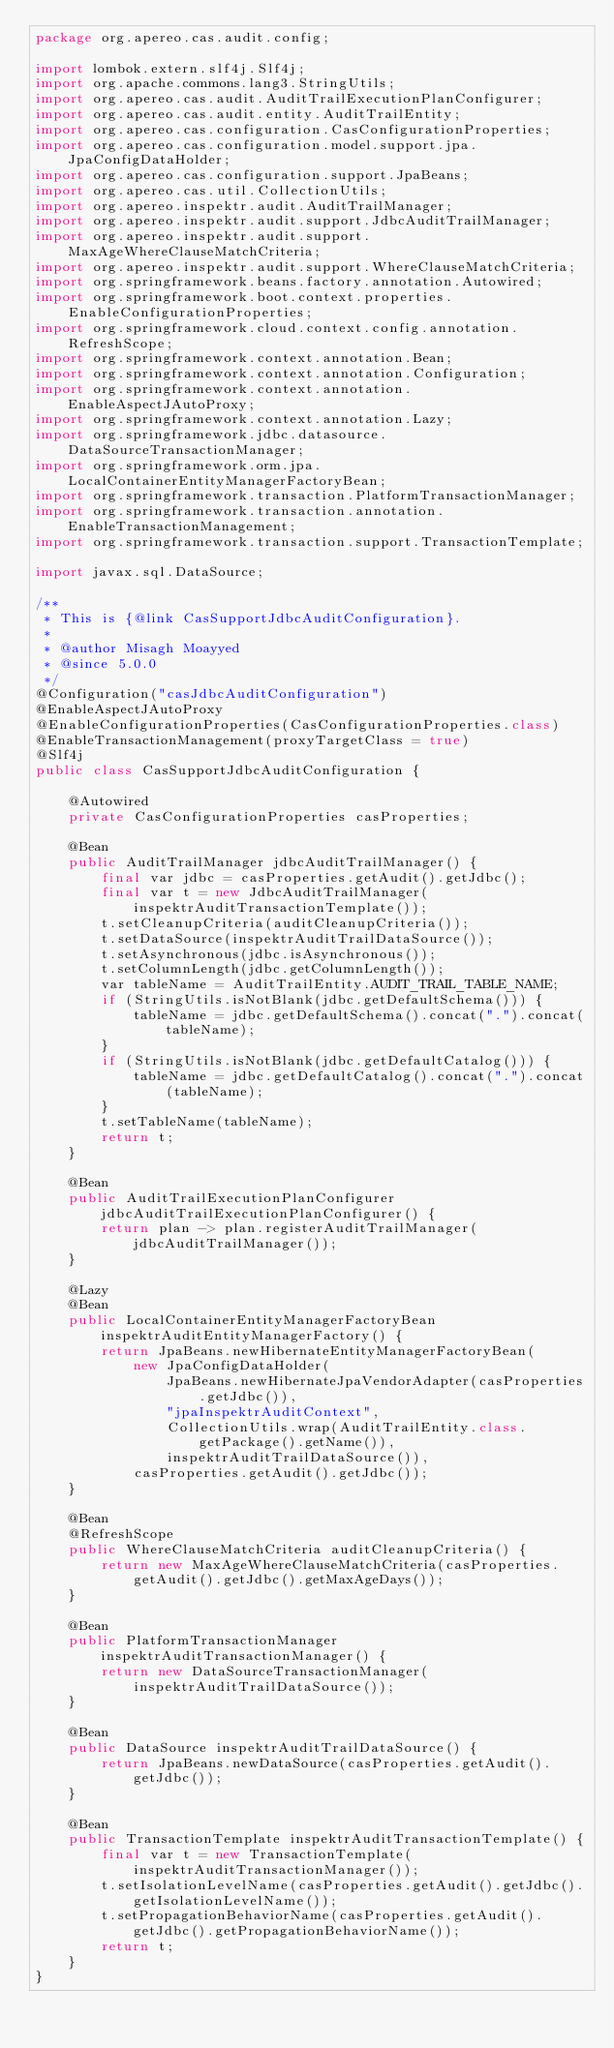<code> <loc_0><loc_0><loc_500><loc_500><_Java_>package org.apereo.cas.audit.config;

import lombok.extern.slf4j.Slf4j;
import org.apache.commons.lang3.StringUtils;
import org.apereo.cas.audit.AuditTrailExecutionPlanConfigurer;
import org.apereo.cas.audit.entity.AuditTrailEntity;
import org.apereo.cas.configuration.CasConfigurationProperties;
import org.apereo.cas.configuration.model.support.jpa.JpaConfigDataHolder;
import org.apereo.cas.configuration.support.JpaBeans;
import org.apereo.cas.util.CollectionUtils;
import org.apereo.inspektr.audit.AuditTrailManager;
import org.apereo.inspektr.audit.support.JdbcAuditTrailManager;
import org.apereo.inspektr.audit.support.MaxAgeWhereClauseMatchCriteria;
import org.apereo.inspektr.audit.support.WhereClauseMatchCriteria;
import org.springframework.beans.factory.annotation.Autowired;
import org.springframework.boot.context.properties.EnableConfigurationProperties;
import org.springframework.cloud.context.config.annotation.RefreshScope;
import org.springframework.context.annotation.Bean;
import org.springframework.context.annotation.Configuration;
import org.springframework.context.annotation.EnableAspectJAutoProxy;
import org.springframework.context.annotation.Lazy;
import org.springframework.jdbc.datasource.DataSourceTransactionManager;
import org.springframework.orm.jpa.LocalContainerEntityManagerFactoryBean;
import org.springframework.transaction.PlatformTransactionManager;
import org.springframework.transaction.annotation.EnableTransactionManagement;
import org.springframework.transaction.support.TransactionTemplate;

import javax.sql.DataSource;

/**
 * This is {@link CasSupportJdbcAuditConfiguration}.
 *
 * @author Misagh Moayyed
 * @since 5.0.0
 */
@Configuration("casJdbcAuditConfiguration")
@EnableAspectJAutoProxy
@EnableConfigurationProperties(CasConfigurationProperties.class)
@EnableTransactionManagement(proxyTargetClass = true)
@Slf4j
public class CasSupportJdbcAuditConfiguration {

    @Autowired
    private CasConfigurationProperties casProperties;

    @Bean
    public AuditTrailManager jdbcAuditTrailManager() {
        final var jdbc = casProperties.getAudit().getJdbc();
        final var t = new JdbcAuditTrailManager(inspektrAuditTransactionTemplate());
        t.setCleanupCriteria(auditCleanupCriteria());
        t.setDataSource(inspektrAuditTrailDataSource());
        t.setAsynchronous(jdbc.isAsynchronous());
        t.setColumnLength(jdbc.getColumnLength());
        var tableName = AuditTrailEntity.AUDIT_TRAIL_TABLE_NAME;
        if (StringUtils.isNotBlank(jdbc.getDefaultSchema())) {
            tableName = jdbc.getDefaultSchema().concat(".").concat(tableName);
        }
        if (StringUtils.isNotBlank(jdbc.getDefaultCatalog())) {
            tableName = jdbc.getDefaultCatalog().concat(".").concat(tableName);
        }
        t.setTableName(tableName);
        return t;
    }

    @Bean
    public AuditTrailExecutionPlanConfigurer jdbcAuditTrailExecutionPlanConfigurer() {
        return plan -> plan.registerAuditTrailManager(jdbcAuditTrailManager());
    }

    @Lazy
    @Bean
    public LocalContainerEntityManagerFactoryBean inspektrAuditEntityManagerFactory() {
        return JpaBeans.newHibernateEntityManagerFactoryBean(
            new JpaConfigDataHolder(
                JpaBeans.newHibernateJpaVendorAdapter(casProperties.getJdbc()),
                "jpaInspektrAuditContext",
                CollectionUtils.wrap(AuditTrailEntity.class.getPackage().getName()),
                inspektrAuditTrailDataSource()),
            casProperties.getAudit().getJdbc());
    }

    @Bean
    @RefreshScope
    public WhereClauseMatchCriteria auditCleanupCriteria() {
        return new MaxAgeWhereClauseMatchCriteria(casProperties.getAudit().getJdbc().getMaxAgeDays());
    }

    @Bean
    public PlatformTransactionManager inspektrAuditTransactionManager() {
        return new DataSourceTransactionManager(inspektrAuditTrailDataSource());
    }

    @Bean
    public DataSource inspektrAuditTrailDataSource() {
        return JpaBeans.newDataSource(casProperties.getAudit().getJdbc());
    }

    @Bean
    public TransactionTemplate inspektrAuditTransactionTemplate() {
        final var t = new TransactionTemplate(inspektrAuditTransactionManager());
        t.setIsolationLevelName(casProperties.getAudit().getJdbc().getIsolationLevelName());
        t.setPropagationBehaviorName(casProperties.getAudit().getJdbc().getPropagationBehaviorName());
        return t;
    }
}
</code> 